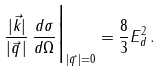Convert formula to latex. <formula><loc_0><loc_0><loc_500><loc_500>\frac { | { \vec { k } } | } { | { \vec { q } \, } | } \, \frac { d \sigma } { d \Omega } \Big | _ { | { \vec { q } \, } | = 0 } = \frac { 8 } { 3 } { E _ { d } ^ { 2 } } \, .</formula> 